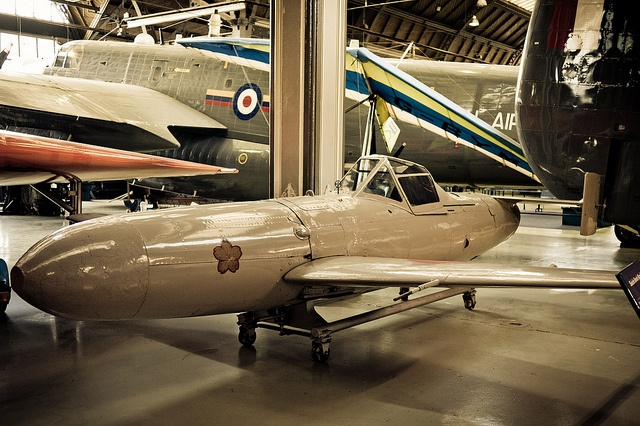Describe the objects in this image and their specific colors. I can see airplane in white, tan, black, gray, and olive tones, airplane in white, black, tan, ivory, and gray tones, and airplane in white, black, tan, and beige tones in this image. 